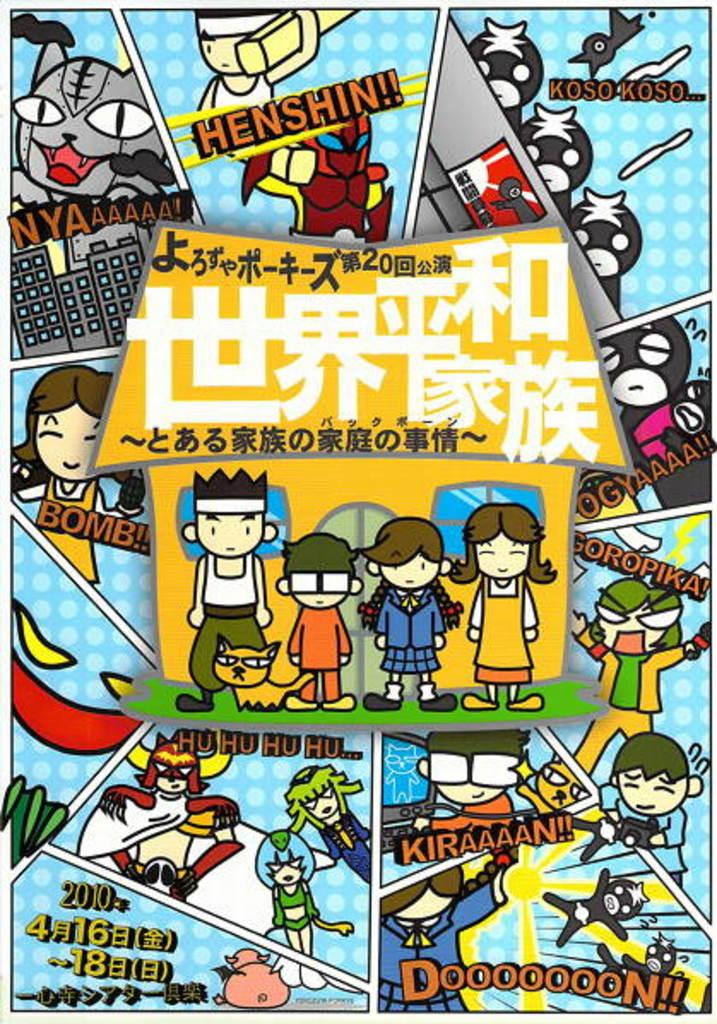<image>
Create a compact narrative representing the image presented. A colorful page from a comic about a family. 